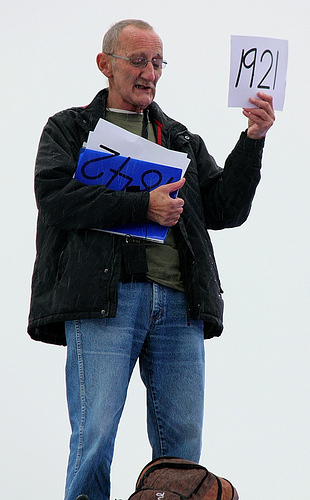<image>
Is the jacket on the man? Yes. Looking at the image, I can see the jacket is positioned on top of the man, with the man providing support. Is the book to the left of the man? No. The book is not to the left of the man. From this viewpoint, they have a different horizontal relationship. 